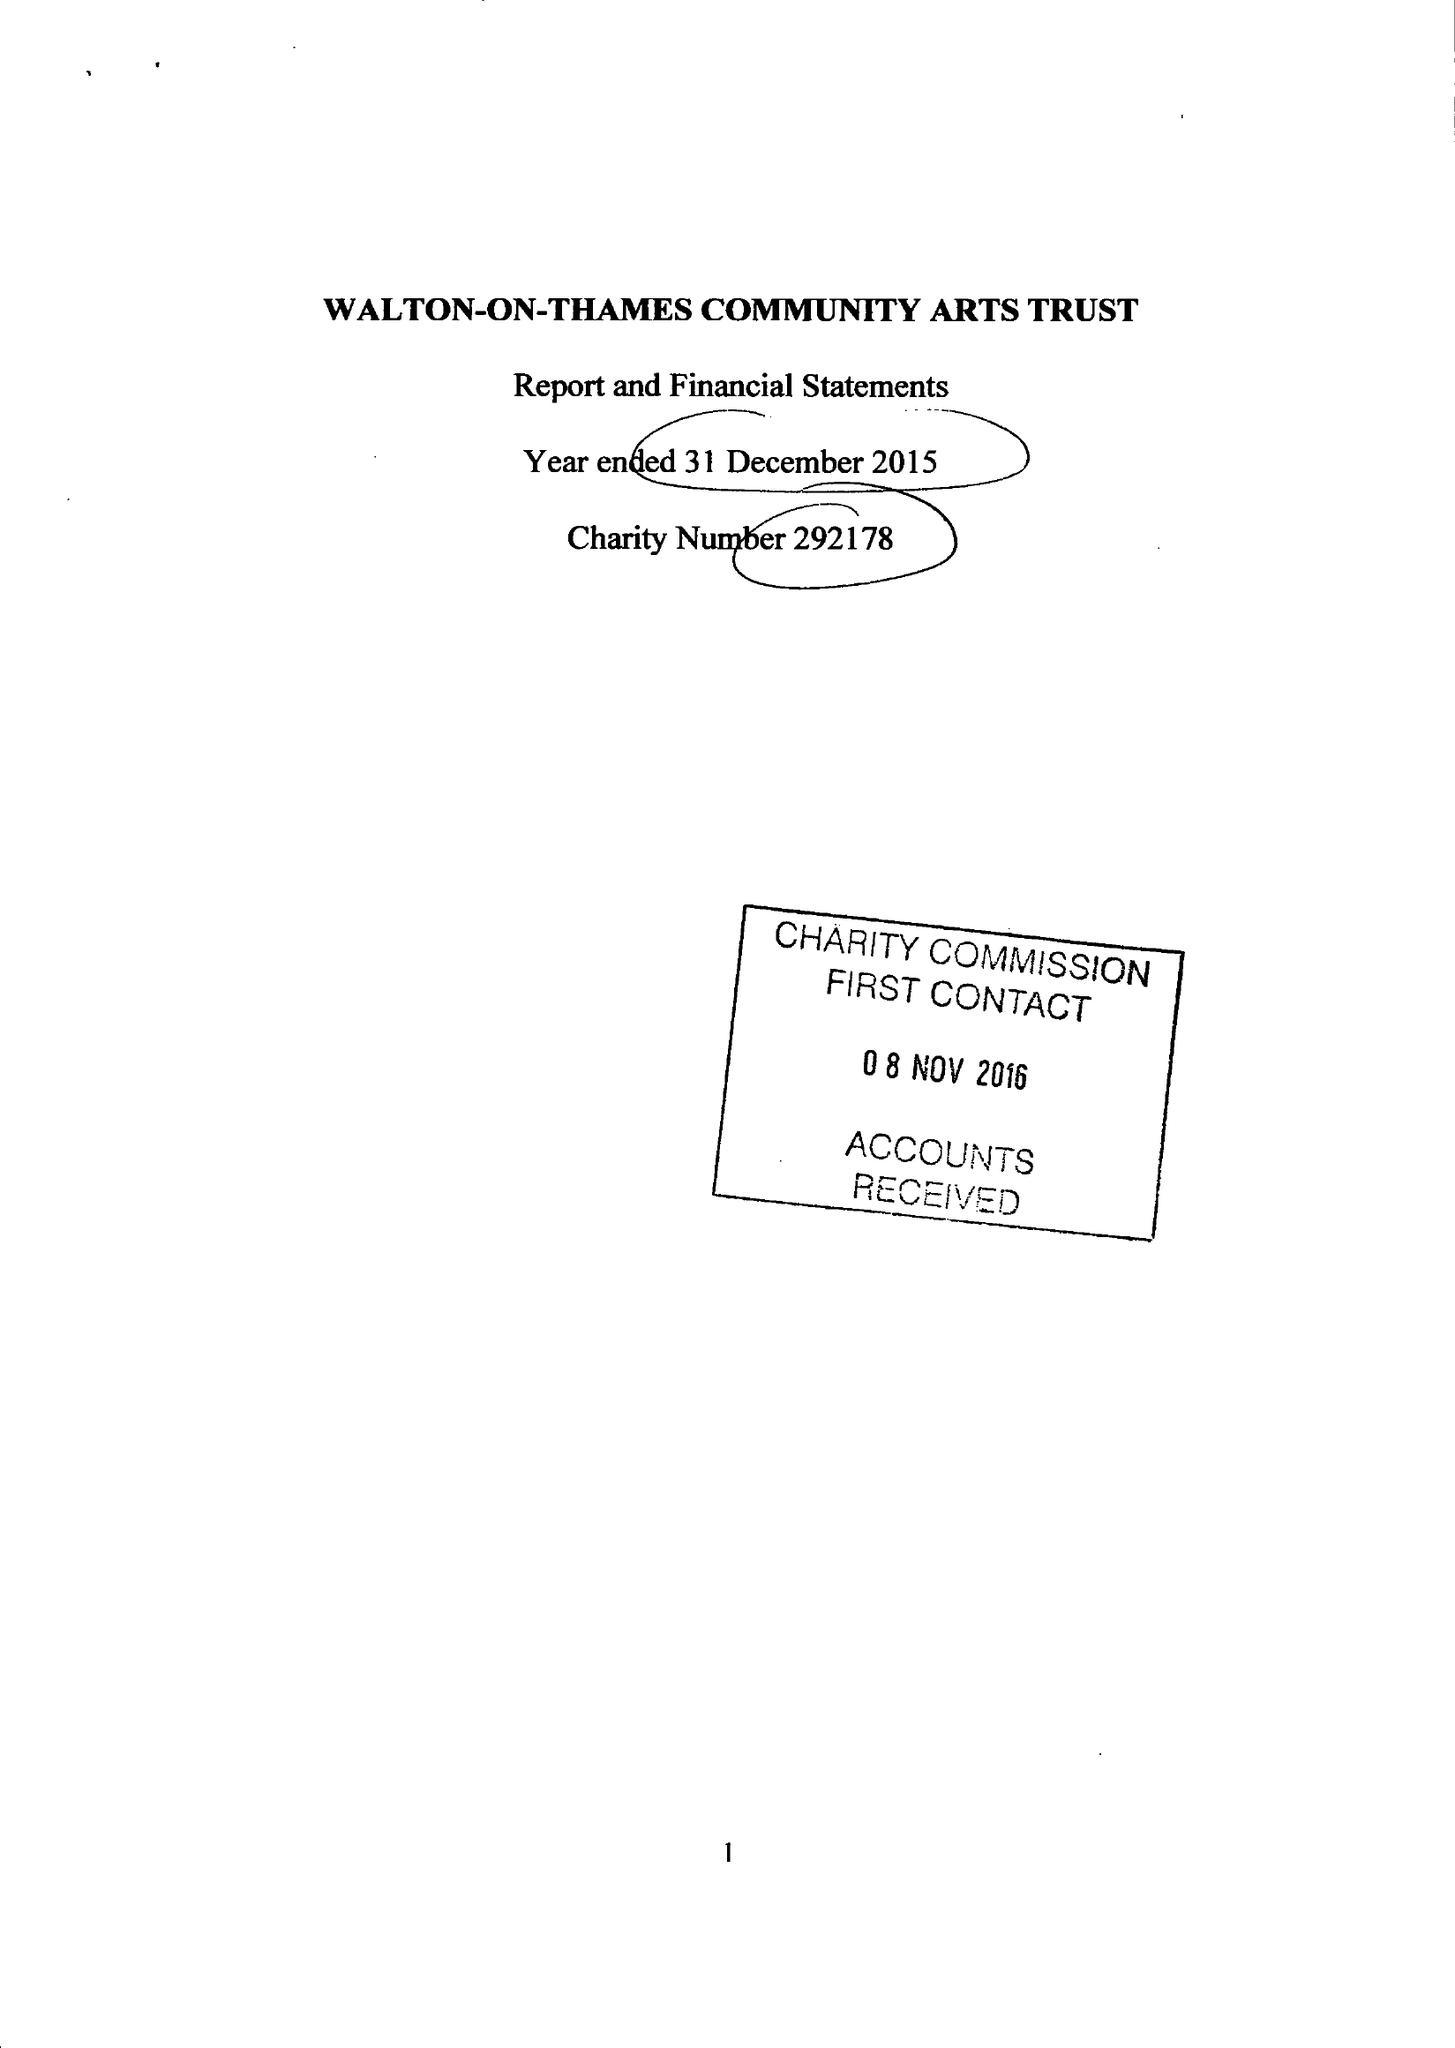What is the value for the charity_number?
Answer the question using a single word or phrase. 292178 